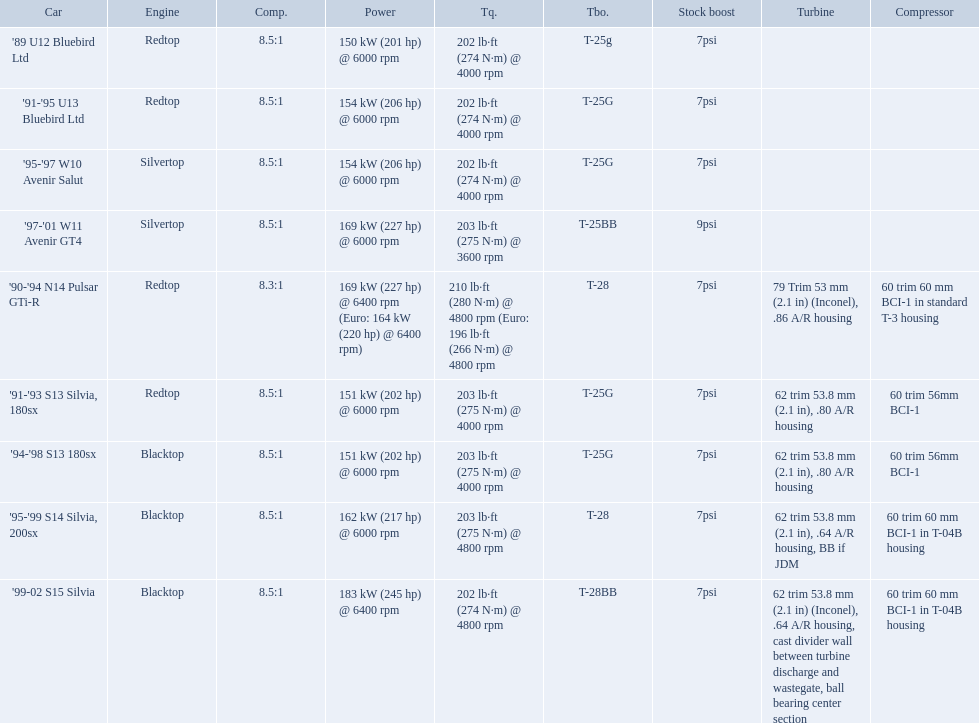What are the listed hp of the cars? 150 kW (201 hp) @ 6000 rpm, 154 kW (206 hp) @ 6000 rpm, 154 kW (206 hp) @ 6000 rpm, 169 kW (227 hp) @ 6000 rpm, 169 kW (227 hp) @ 6400 rpm (Euro: 164 kW (220 hp) @ 6400 rpm), 151 kW (202 hp) @ 6000 rpm, 151 kW (202 hp) @ 6000 rpm, 162 kW (217 hp) @ 6000 rpm, 183 kW (245 hp) @ 6400 rpm. Which is the only car with over 230 hp? '99-02 S15 Silvia. I'm looking to parse the entire table for insights. Could you assist me with that? {'header': ['Car', 'Engine', 'Comp.', 'Power', 'Tq.', 'Tbo.', 'Stock boost', 'Turbine', 'Compressor'], 'rows': [["'89 U12 Bluebird Ltd", 'Redtop', '8.5:1', '150\xa0kW (201\xa0hp) @ 6000 rpm', '202\xa0lb·ft (274\xa0N·m) @ 4000 rpm', 'T-25g', '7psi', '', ''], ["'91-'95 U13 Bluebird Ltd", 'Redtop', '8.5:1', '154\xa0kW (206\xa0hp) @ 6000 rpm', '202\xa0lb·ft (274\xa0N·m) @ 4000 rpm', 'T-25G', '7psi', '', ''], ["'95-'97 W10 Avenir Salut", 'Silvertop', '8.5:1', '154\xa0kW (206\xa0hp) @ 6000 rpm', '202\xa0lb·ft (274\xa0N·m) @ 4000 rpm', 'T-25G', '7psi', '', ''], ["'97-'01 W11 Avenir GT4", 'Silvertop', '8.5:1', '169\xa0kW (227\xa0hp) @ 6000 rpm', '203\xa0lb·ft (275\xa0N·m) @ 3600 rpm', 'T-25BB', '9psi', '', ''], ["'90-'94 N14 Pulsar GTi-R", 'Redtop', '8.3:1', '169\xa0kW (227\xa0hp) @ 6400 rpm (Euro: 164\xa0kW (220\xa0hp) @ 6400 rpm)', '210\xa0lb·ft (280\xa0N·m) @ 4800 rpm (Euro: 196\xa0lb·ft (266\xa0N·m) @ 4800 rpm', 'T-28', '7psi', '79 Trim 53\xa0mm (2.1\xa0in) (Inconel), .86 A/R housing', '60 trim 60\xa0mm BCI-1 in standard T-3 housing'], ["'91-'93 S13 Silvia, 180sx", 'Redtop', '8.5:1', '151\xa0kW (202\xa0hp) @ 6000 rpm', '203\xa0lb·ft (275\xa0N·m) @ 4000 rpm', 'T-25G', '7psi', '62 trim 53.8\xa0mm (2.1\xa0in), .80 A/R housing', '60 trim 56mm BCI-1'], ["'94-'98 S13 180sx", 'Blacktop', '8.5:1', '151\xa0kW (202\xa0hp) @ 6000 rpm', '203\xa0lb·ft (275\xa0N·m) @ 4000 rpm', 'T-25G', '7psi', '62 trim 53.8\xa0mm (2.1\xa0in), .80 A/R housing', '60 trim 56mm BCI-1'], ["'95-'99 S14 Silvia, 200sx", 'Blacktop', '8.5:1', '162\xa0kW (217\xa0hp) @ 6000 rpm', '203\xa0lb·ft (275\xa0N·m) @ 4800 rpm', 'T-28', '7psi', '62 trim 53.8\xa0mm (2.1\xa0in), .64 A/R housing, BB if JDM', '60 trim 60\xa0mm BCI-1 in T-04B housing'], ["'99-02 S15 Silvia", 'Blacktop', '8.5:1', '183\xa0kW (245\xa0hp) @ 6400 rpm', '202\xa0lb·ft (274\xa0N·m) @ 4800 rpm', 'T-28BB', '7psi', '62 trim 53.8\xa0mm (2.1\xa0in) (Inconel), .64 A/R housing, cast divider wall between turbine discharge and wastegate, ball bearing center section', '60 trim 60\xa0mm BCI-1 in T-04B housing']]} What are all the cars? '89 U12 Bluebird Ltd, '91-'95 U13 Bluebird Ltd, '95-'97 W10 Avenir Salut, '97-'01 W11 Avenir GT4, '90-'94 N14 Pulsar GTi-R, '91-'93 S13 Silvia, 180sx, '94-'98 S13 180sx, '95-'99 S14 Silvia, 200sx, '99-02 S15 Silvia. What are their stock boosts? 7psi, 7psi, 7psi, 9psi, 7psi, 7psi, 7psi, 7psi, 7psi. And which car has the highest stock boost? '97-'01 W11 Avenir GT4. What are all of the nissan cars? '89 U12 Bluebird Ltd, '91-'95 U13 Bluebird Ltd, '95-'97 W10 Avenir Salut, '97-'01 W11 Avenir GT4, '90-'94 N14 Pulsar GTi-R, '91-'93 S13 Silvia, 180sx, '94-'98 S13 180sx, '95-'99 S14 Silvia, 200sx, '99-02 S15 Silvia. Of these cars, which one is a '90-'94 n14 pulsar gti-r? '90-'94 N14 Pulsar GTi-R. What is the compression of this car? 8.3:1. Which of the cars uses the redtop engine? '89 U12 Bluebird Ltd, '91-'95 U13 Bluebird Ltd, '90-'94 N14 Pulsar GTi-R, '91-'93 S13 Silvia, 180sx. Of these, has more than 220 horsepower? '90-'94 N14 Pulsar GTi-R. What is the compression ratio of this car? 8.3:1. 